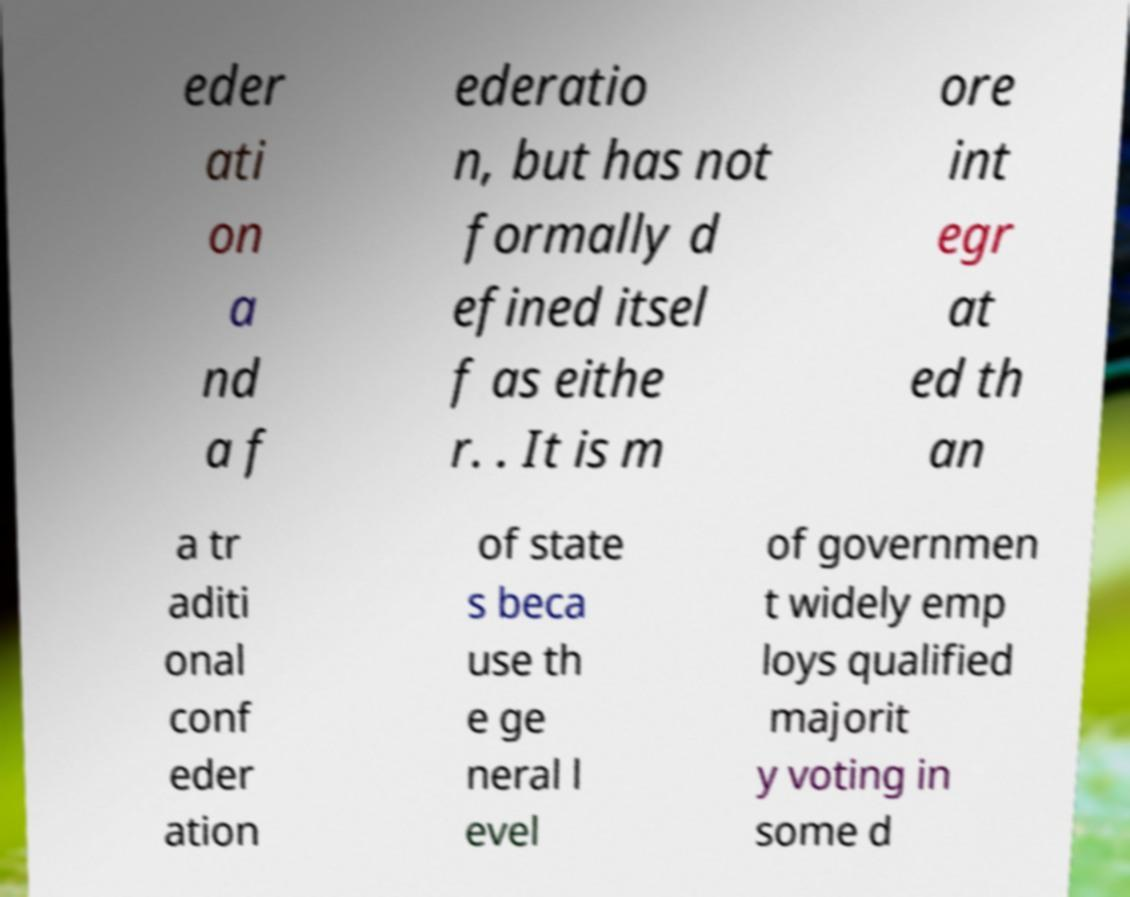Please identify and transcribe the text found in this image. eder ati on a nd a f ederatio n, but has not formally d efined itsel f as eithe r. . It is m ore int egr at ed th an a tr aditi onal conf eder ation of state s beca use th e ge neral l evel of governmen t widely emp loys qualified majorit y voting in some d 